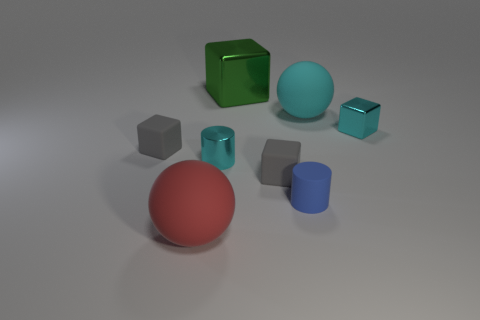Can you describe the various objects and their materials in this image? Certainly! In the image, there is a collection of geometric shapes with different materials. There's a red rubber sphere, a cyan matte sphere, and a green glass cube, all exhibiting distinct textures and light interactions. There are also grey metallic cubes and cylinders along with a shiny cyan metallic cube, reflecting light sharply and giving a sense of variety in textures. 